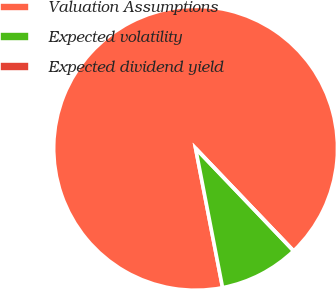Convert chart to OTSL. <chart><loc_0><loc_0><loc_500><loc_500><pie_chart><fcel>Valuation Assumptions<fcel>Expected volatility<fcel>Expected dividend yield<nl><fcel>90.9%<fcel>9.09%<fcel>0.0%<nl></chart> 